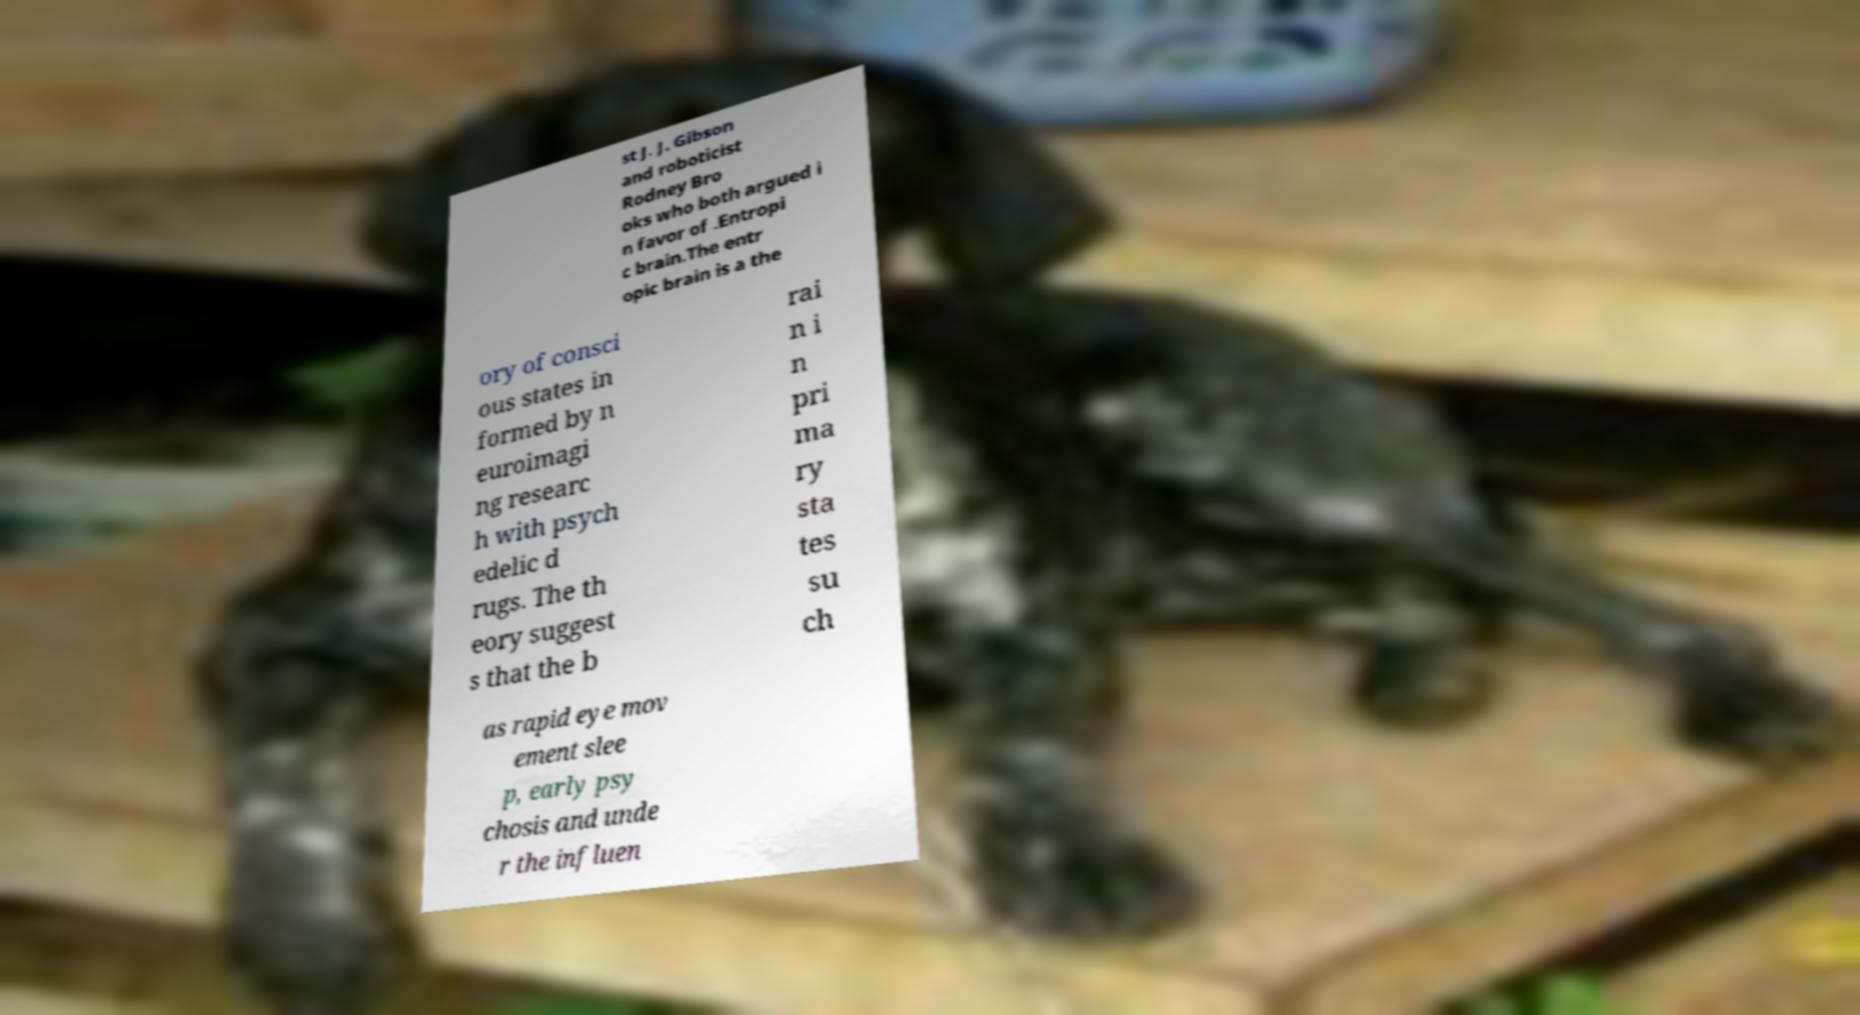Please read and relay the text visible in this image. What does it say? st J. J. Gibson and roboticist Rodney Bro oks who both argued i n favor of .Entropi c brain.The entr opic brain is a the ory of consci ous states in formed by n euroimagi ng researc h with psych edelic d rugs. The th eory suggest s that the b rai n i n pri ma ry sta tes su ch as rapid eye mov ement slee p, early psy chosis and unde r the influen 